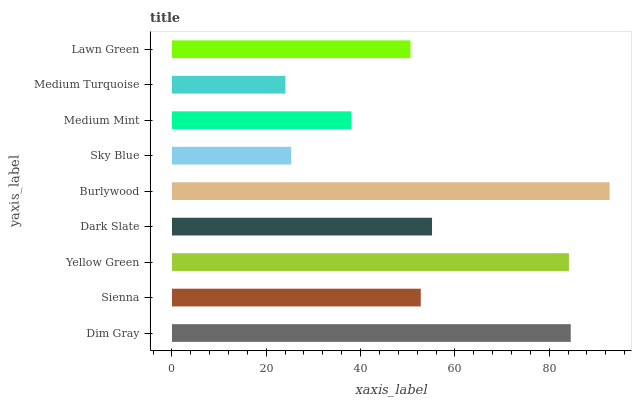Is Medium Turquoise the minimum?
Answer yes or no. Yes. Is Burlywood the maximum?
Answer yes or no. Yes. Is Sienna the minimum?
Answer yes or no. No. Is Sienna the maximum?
Answer yes or no. No. Is Dim Gray greater than Sienna?
Answer yes or no. Yes. Is Sienna less than Dim Gray?
Answer yes or no. Yes. Is Sienna greater than Dim Gray?
Answer yes or no. No. Is Dim Gray less than Sienna?
Answer yes or no. No. Is Sienna the high median?
Answer yes or no. Yes. Is Sienna the low median?
Answer yes or no. Yes. Is Dark Slate the high median?
Answer yes or no. No. Is Burlywood the low median?
Answer yes or no. No. 